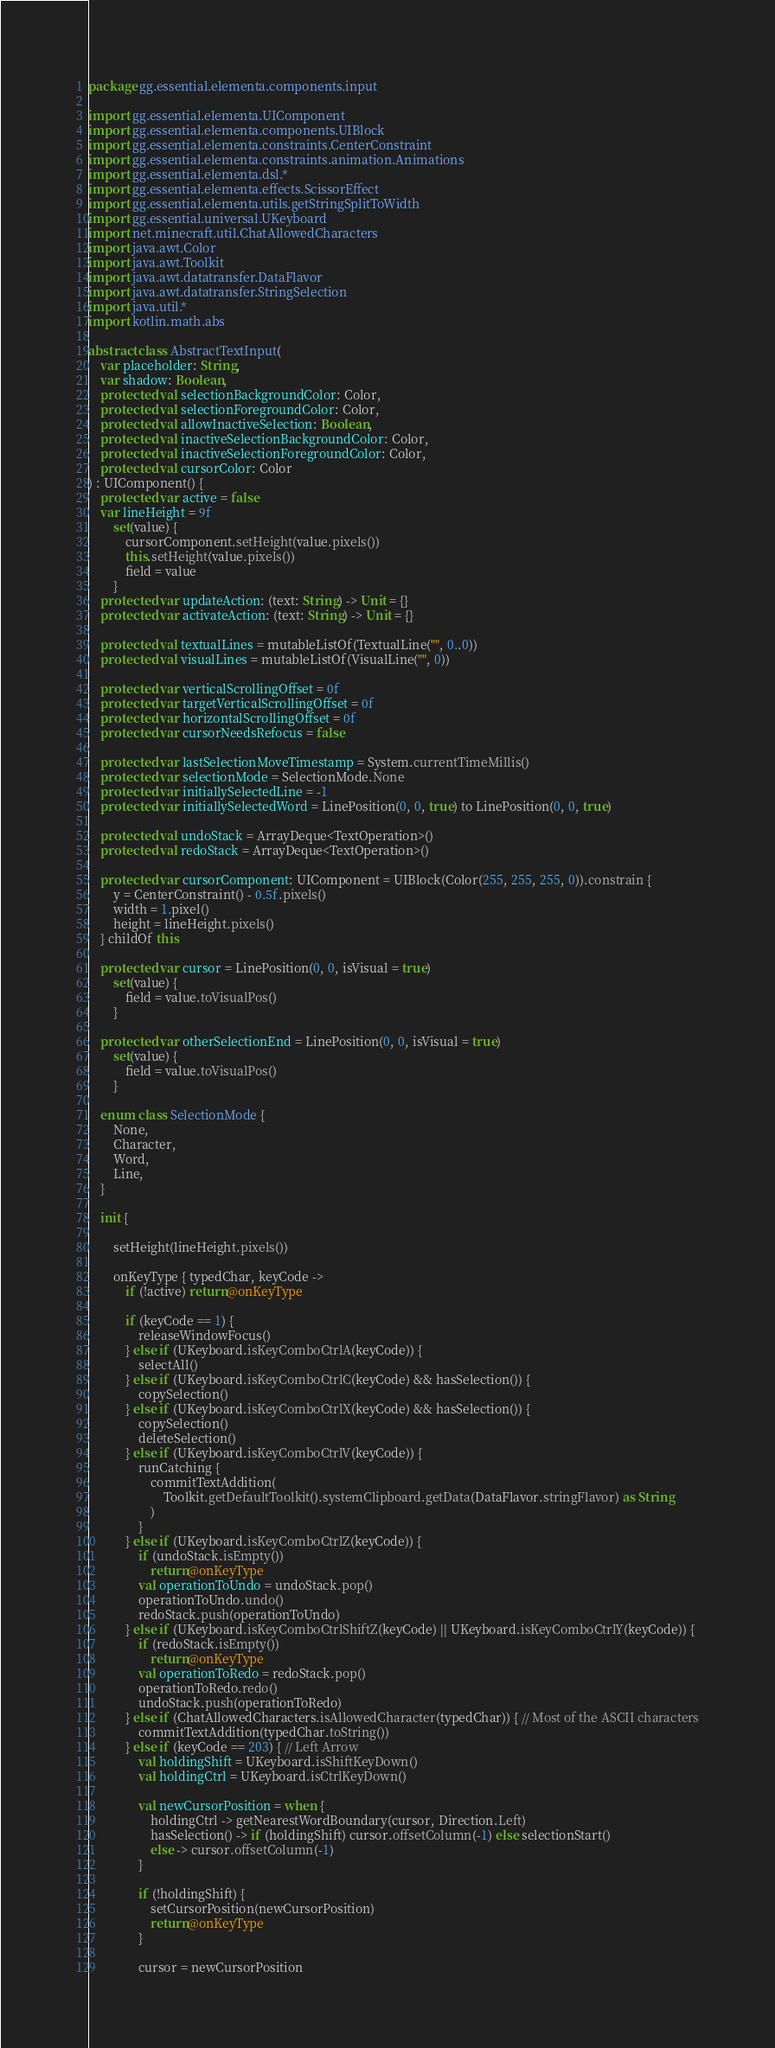<code> <loc_0><loc_0><loc_500><loc_500><_Kotlin_>package gg.essential.elementa.components.input

import gg.essential.elementa.UIComponent
import gg.essential.elementa.components.UIBlock
import gg.essential.elementa.constraints.CenterConstraint
import gg.essential.elementa.constraints.animation.Animations
import gg.essential.elementa.dsl.*
import gg.essential.elementa.effects.ScissorEffect
import gg.essential.elementa.utils.getStringSplitToWidth
import gg.essential.universal.UKeyboard
import net.minecraft.util.ChatAllowedCharacters
import java.awt.Color
import java.awt.Toolkit
import java.awt.datatransfer.DataFlavor
import java.awt.datatransfer.StringSelection
import java.util.*
import kotlin.math.abs

abstract class AbstractTextInput(
    var placeholder: String,
    var shadow: Boolean,
    protected val selectionBackgroundColor: Color,
    protected val selectionForegroundColor: Color,
    protected val allowInactiveSelection: Boolean,
    protected val inactiveSelectionBackgroundColor: Color,
    protected val inactiveSelectionForegroundColor: Color,
    protected val cursorColor: Color
) : UIComponent() {
    protected var active = false
    var lineHeight = 9f
        set(value) {
            cursorComponent.setHeight(value.pixels())
            this.setHeight(value.pixels())
            field = value
        }
    protected var updateAction: (text: String) -> Unit = {}
    protected var activateAction: (text: String) -> Unit = {}

    protected val textualLines = mutableListOf(TextualLine("", 0..0))
    protected val visualLines = mutableListOf(VisualLine("", 0))

    protected var verticalScrollingOffset = 0f
    protected var targetVerticalScrollingOffset = 0f
    protected var horizontalScrollingOffset = 0f
    protected var cursorNeedsRefocus = false

    protected var lastSelectionMoveTimestamp = System.currentTimeMillis()
    protected var selectionMode = SelectionMode.None
    protected var initiallySelectedLine = -1
    protected var initiallySelectedWord = LinePosition(0, 0, true) to LinePosition(0, 0, true)

    protected val undoStack = ArrayDeque<TextOperation>()
    protected val redoStack = ArrayDeque<TextOperation>()

    protected var cursorComponent: UIComponent = UIBlock(Color(255, 255, 255, 0)).constrain {
        y = CenterConstraint() - 0.5f.pixels()
        width = 1.pixel()
        height = lineHeight.pixels()
    } childOf this

    protected var cursor = LinePosition(0, 0, isVisual = true)
        set(value) {
            field = value.toVisualPos()
        }

    protected var otherSelectionEnd = LinePosition(0, 0, isVisual = true)
        set(value) {
            field = value.toVisualPos()
        }

    enum class SelectionMode {
        None,
        Character,
        Word,
        Line,
    }

    init {

        setHeight(lineHeight.pixels())

        onKeyType { typedChar, keyCode ->
            if (!active) return@onKeyType

            if (keyCode == 1) {
                releaseWindowFocus()
            } else if (UKeyboard.isKeyComboCtrlA(keyCode)) {
                selectAll()
            } else if (UKeyboard.isKeyComboCtrlC(keyCode) && hasSelection()) {
                copySelection()
            } else if (UKeyboard.isKeyComboCtrlX(keyCode) && hasSelection()) {
                copySelection()
                deleteSelection()
            } else if (UKeyboard.isKeyComboCtrlV(keyCode)) {
                runCatching {
                    commitTextAddition(
                        Toolkit.getDefaultToolkit().systemClipboard.getData(DataFlavor.stringFlavor) as String
                    )
                }
            } else if (UKeyboard.isKeyComboCtrlZ(keyCode)) {
                if (undoStack.isEmpty())
                    return@onKeyType
                val operationToUndo = undoStack.pop()
                operationToUndo.undo()
                redoStack.push(operationToUndo)
            } else if (UKeyboard.isKeyComboCtrlShiftZ(keyCode) || UKeyboard.isKeyComboCtrlY(keyCode)) {
                if (redoStack.isEmpty())
                    return@onKeyType
                val operationToRedo = redoStack.pop()
                operationToRedo.redo()
                undoStack.push(operationToRedo)
            } else if (ChatAllowedCharacters.isAllowedCharacter(typedChar)) { // Most of the ASCII characters
                commitTextAddition(typedChar.toString())
            } else if (keyCode == 203) { // Left Arrow
                val holdingShift = UKeyboard.isShiftKeyDown()
                val holdingCtrl = UKeyboard.isCtrlKeyDown()

                val newCursorPosition = when {
                    holdingCtrl -> getNearestWordBoundary(cursor, Direction.Left)
                    hasSelection() -> if (holdingShift) cursor.offsetColumn(-1) else selectionStart()
                    else -> cursor.offsetColumn(-1)
                }

                if (!holdingShift) {
                    setCursorPosition(newCursorPosition)
                    return@onKeyType
                }

                cursor = newCursorPosition</code> 